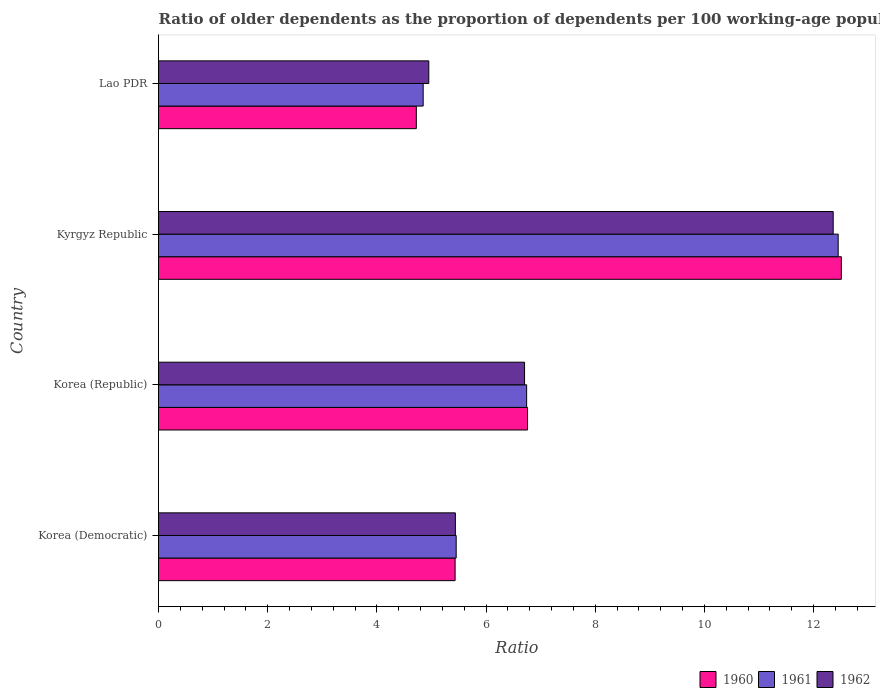How many different coloured bars are there?
Your answer should be very brief. 3. How many groups of bars are there?
Offer a terse response. 4. Are the number of bars per tick equal to the number of legend labels?
Your answer should be compact. Yes. Are the number of bars on each tick of the Y-axis equal?
Offer a terse response. Yes. How many bars are there on the 2nd tick from the bottom?
Provide a short and direct response. 3. What is the label of the 3rd group of bars from the top?
Ensure brevity in your answer.  Korea (Republic). What is the age dependency ratio(old) in 1960 in Korea (Democratic)?
Offer a very short reply. 5.43. Across all countries, what is the maximum age dependency ratio(old) in 1960?
Keep it short and to the point. 12.51. Across all countries, what is the minimum age dependency ratio(old) in 1960?
Offer a terse response. 4.72. In which country was the age dependency ratio(old) in 1960 maximum?
Your response must be concise. Kyrgyz Republic. In which country was the age dependency ratio(old) in 1961 minimum?
Provide a succinct answer. Lao PDR. What is the total age dependency ratio(old) in 1961 in the graph?
Your response must be concise. 29.49. What is the difference between the age dependency ratio(old) in 1962 in Kyrgyz Republic and that in Lao PDR?
Ensure brevity in your answer.  7.41. What is the difference between the age dependency ratio(old) in 1960 in Korea (Democratic) and the age dependency ratio(old) in 1962 in Korea (Republic)?
Your response must be concise. -1.27. What is the average age dependency ratio(old) in 1962 per country?
Your answer should be compact. 7.36. What is the difference between the age dependency ratio(old) in 1960 and age dependency ratio(old) in 1962 in Korea (Republic)?
Make the answer very short. 0.05. What is the ratio of the age dependency ratio(old) in 1962 in Kyrgyz Republic to that in Lao PDR?
Provide a succinct answer. 2.5. Is the age dependency ratio(old) in 1960 in Korea (Democratic) less than that in Lao PDR?
Your response must be concise. No. Is the difference between the age dependency ratio(old) in 1960 in Kyrgyz Republic and Lao PDR greater than the difference between the age dependency ratio(old) in 1962 in Kyrgyz Republic and Lao PDR?
Offer a very short reply. Yes. What is the difference between the highest and the second highest age dependency ratio(old) in 1962?
Your answer should be very brief. 5.65. What is the difference between the highest and the lowest age dependency ratio(old) in 1962?
Keep it short and to the point. 7.41. Is the sum of the age dependency ratio(old) in 1962 in Korea (Democratic) and Lao PDR greater than the maximum age dependency ratio(old) in 1960 across all countries?
Your answer should be very brief. No. Is it the case that in every country, the sum of the age dependency ratio(old) in 1960 and age dependency ratio(old) in 1961 is greater than the age dependency ratio(old) in 1962?
Provide a short and direct response. Yes. How many bars are there?
Provide a short and direct response. 12. Are all the bars in the graph horizontal?
Offer a very short reply. Yes. How many countries are there in the graph?
Your answer should be very brief. 4. What is the difference between two consecutive major ticks on the X-axis?
Your answer should be very brief. 2. Are the values on the major ticks of X-axis written in scientific E-notation?
Provide a succinct answer. No. Does the graph contain grids?
Provide a succinct answer. No. Where does the legend appear in the graph?
Your answer should be compact. Bottom right. How are the legend labels stacked?
Provide a succinct answer. Horizontal. What is the title of the graph?
Offer a very short reply. Ratio of older dependents as the proportion of dependents per 100 working-age population. What is the label or title of the X-axis?
Give a very brief answer. Ratio. What is the Ratio in 1960 in Korea (Democratic)?
Your answer should be compact. 5.43. What is the Ratio in 1961 in Korea (Democratic)?
Give a very brief answer. 5.45. What is the Ratio of 1962 in Korea (Democratic)?
Your answer should be compact. 5.44. What is the Ratio in 1960 in Korea (Republic)?
Your response must be concise. 6.76. What is the Ratio of 1961 in Korea (Republic)?
Your answer should be very brief. 6.74. What is the Ratio of 1962 in Korea (Republic)?
Offer a very short reply. 6.7. What is the Ratio of 1960 in Kyrgyz Republic?
Your answer should be very brief. 12.51. What is the Ratio of 1961 in Kyrgyz Republic?
Offer a very short reply. 12.45. What is the Ratio in 1962 in Kyrgyz Republic?
Your response must be concise. 12.36. What is the Ratio in 1960 in Lao PDR?
Ensure brevity in your answer.  4.72. What is the Ratio of 1961 in Lao PDR?
Your response must be concise. 4.85. What is the Ratio in 1962 in Lao PDR?
Make the answer very short. 4.95. Across all countries, what is the maximum Ratio in 1960?
Provide a succinct answer. 12.51. Across all countries, what is the maximum Ratio of 1961?
Give a very brief answer. 12.45. Across all countries, what is the maximum Ratio in 1962?
Offer a very short reply. 12.36. Across all countries, what is the minimum Ratio in 1960?
Offer a very short reply. 4.72. Across all countries, what is the minimum Ratio of 1961?
Make the answer very short. 4.85. Across all countries, what is the minimum Ratio in 1962?
Your answer should be very brief. 4.95. What is the total Ratio of 1960 in the graph?
Offer a terse response. 29.42. What is the total Ratio in 1961 in the graph?
Give a very brief answer. 29.49. What is the total Ratio of 1962 in the graph?
Provide a succinct answer. 29.45. What is the difference between the Ratio of 1960 in Korea (Democratic) and that in Korea (Republic)?
Offer a terse response. -1.33. What is the difference between the Ratio of 1961 in Korea (Democratic) and that in Korea (Republic)?
Your response must be concise. -1.29. What is the difference between the Ratio of 1962 in Korea (Democratic) and that in Korea (Republic)?
Offer a very short reply. -1.27. What is the difference between the Ratio in 1960 in Korea (Democratic) and that in Kyrgyz Republic?
Make the answer very short. -7.07. What is the difference between the Ratio of 1961 in Korea (Democratic) and that in Kyrgyz Republic?
Provide a short and direct response. -7. What is the difference between the Ratio of 1962 in Korea (Democratic) and that in Kyrgyz Republic?
Offer a very short reply. -6.92. What is the difference between the Ratio in 1960 in Korea (Democratic) and that in Lao PDR?
Offer a very short reply. 0.71. What is the difference between the Ratio of 1961 in Korea (Democratic) and that in Lao PDR?
Ensure brevity in your answer.  0.6. What is the difference between the Ratio in 1962 in Korea (Democratic) and that in Lao PDR?
Keep it short and to the point. 0.49. What is the difference between the Ratio of 1960 in Korea (Republic) and that in Kyrgyz Republic?
Provide a succinct answer. -5.75. What is the difference between the Ratio in 1961 in Korea (Republic) and that in Kyrgyz Republic?
Ensure brevity in your answer.  -5.71. What is the difference between the Ratio in 1962 in Korea (Republic) and that in Kyrgyz Republic?
Make the answer very short. -5.65. What is the difference between the Ratio of 1960 in Korea (Republic) and that in Lao PDR?
Give a very brief answer. 2.04. What is the difference between the Ratio in 1961 in Korea (Republic) and that in Lao PDR?
Your answer should be compact. 1.9. What is the difference between the Ratio in 1962 in Korea (Republic) and that in Lao PDR?
Keep it short and to the point. 1.75. What is the difference between the Ratio of 1960 in Kyrgyz Republic and that in Lao PDR?
Give a very brief answer. 7.78. What is the difference between the Ratio of 1961 in Kyrgyz Republic and that in Lao PDR?
Ensure brevity in your answer.  7.6. What is the difference between the Ratio of 1962 in Kyrgyz Republic and that in Lao PDR?
Make the answer very short. 7.41. What is the difference between the Ratio in 1960 in Korea (Democratic) and the Ratio in 1961 in Korea (Republic)?
Make the answer very short. -1.31. What is the difference between the Ratio of 1960 in Korea (Democratic) and the Ratio of 1962 in Korea (Republic)?
Offer a terse response. -1.27. What is the difference between the Ratio in 1961 in Korea (Democratic) and the Ratio in 1962 in Korea (Republic)?
Give a very brief answer. -1.25. What is the difference between the Ratio of 1960 in Korea (Democratic) and the Ratio of 1961 in Kyrgyz Republic?
Give a very brief answer. -7.02. What is the difference between the Ratio of 1960 in Korea (Democratic) and the Ratio of 1962 in Kyrgyz Republic?
Your answer should be very brief. -6.93. What is the difference between the Ratio of 1961 in Korea (Democratic) and the Ratio of 1962 in Kyrgyz Republic?
Your answer should be compact. -6.91. What is the difference between the Ratio in 1960 in Korea (Democratic) and the Ratio in 1961 in Lao PDR?
Keep it short and to the point. 0.59. What is the difference between the Ratio of 1960 in Korea (Democratic) and the Ratio of 1962 in Lao PDR?
Keep it short and to the point. 0.48. What is the difference between the Ratio of 1961 in Korea (Democratic) and the Ratio of 1962 in Lao PDR?
Keep it short and to the point. 0.5. What is the difference between the Ratio in 1960 in Korea (Republic) and the Ratio in 1961 in Kyrgyz Republic?
Ensure brevity in your answer.  -5.69. What is the difference between the Ratio in 1960 in Korea (Republic) and the Ratio in 1962 in Kyrgyz Republic?
Provide a short and direct response. -5.6. What is the difference between the Ratio in 1961 in Korea (Republic) and the Ratio in 1962 in Kyrgyz Republic?
Give a very brief answer. -5.61. What is the difference between the Ratio in 1960 in Korea (Republic) and the Ratio in 1961 in Lao PDR?
Make the answer very short. 1.91. What is the difference between the Ratio of 1960 in Korea (Republic) and the Ratio of 1962 in Lao PDR?
Offer a terse response. 1.81. What is the difference between the Ratio in 1961 in Korea (Republic) and the Ratio in 1962 in Lao PDR?
Give a very brief answer. 1.79. What is the difference between the Ratio in 1960 in Kyrgyz Republic and the Ratio in 1961 in Lao PDR?
Offer a terse response. 7.66. What is the difference between the Ratio in 1960 in Kyrgyz Republic and the Ratio in 1962 in Lao PDR?
Your answer should be compact. 7.56. What is the difference between the Ratio in 1961 in Kyrgyz Republic and the Ratio in 1962 in Lao PDR?
Provide a succinct answer. 7.5. What is the average Ratio in 1960 per country?
Keep it short and to the point. 7.36. What is the average Ratio of 1961 per country?
Keep it short and to the point. 7.37. What is the average Ratio of 1962 per country?
Provide a short and direct response. 7.36. What is the difference between the Ratio of 1960 and Ratio of 1961 in Korea (Democratic)?
Ensure brevity in your answer.  -0.02. What is the difference between the Ratio of 1960 and Ratio of 1962 in Korea (Democratic)?
Give a very brief answer. -0. What is the difference between the Ratio in 1961 and Ratio in 1962 in Korea (Democratic)?
Keep it short and to the point. 0.01. What is the difference between the Ratio in 1960 and Ratio in 1961 in Korea (Republic)?
Offer a very short reply. 0.02. What is the difference between the Ratio in 1960 and Ratio in 1962 in Korea (Republic)?
Offer a very short reply. 0.05. What is the difference between the Ratio of 1961 and Ratio of 1962 in Korea (Republic)?
Ensure brevity in your answer.  0.04. What is the difference between the Ratio of 1960 and Ratio of 1961 in Kyrgyz Republic?
Make the answer very short. 0.06. What is the difference between the Ratio in 1960 and Ratio in 1962 in Kyrgyz Republic?
Keep it short and to the point. 0.15. What is the difference between the Ratio in 1961 and Ratio in 1962 in Kyrgyz Republic?
Keep it short and to the point. 0.09. What is the difference between the Ratio in 1960 and Ratio in 1961 in Lao PDR?
Provide a short and direct response. -0.13. What is the difference between the Ratio of 1960 and Ratio of 1962 in Lao PDR?
Give a very brief answer. -0.23. What is the difference between the Ratio of 1961 and Ratio of 1962 in Lao PDR?
Your answer should be compact. -0.1. What is the ratio of the Ratio of 1960 in Korea (Democratic) to that in Korea (Republic)?
Your answer should be compact. 0.8. What is the ratio of the Ratio of 1961 in Korea (Democratic) to that in Korea (Republic)?
Make the answer very short. 0.81. What is the ratio of the Ratio in 1962 in Korea (Democratic) to that in Korea (Republic)?
Provide a short and direct response. 0.81. What is the ratio of the Ratio in 1960 in Korea (Democratic) to that in Kyrgyz Republic?
Your response must be concise. 0.43. What is the ratio of the Ratio in 1961 in Korea (Democratic) to that in Kyrgyz Republic?
Your answer should be very brief. 0.44. What is the ratio of the Ratio of 1962 in Korea (Democratic) to that in Kyrgyz Republic?
Offer a terse response. 0.44. What is the ratio of the Ratio in 1960 in Korea (Democratic) to that in Lao PDR?
Keep it short and to the point. 1.15. What is the ratio of the Ratio of 1961 in Korea (Democratic) to that in Lao PDR?
Keep it short and to the point. 1.12. What is the ratio of the Ratio of 1962 in Korea (Democratic) to that in Lao PDR?
Your answer should be very brief. 1.1. What is the ratio of the Ratio in 1960 in Korea (Republic) to that in Kyrgyz Republic?
Your answer should be compact. 0.54. What is the ratio of the Ratio in 1961 in Korea (Republic) to that in Kyrgyz Republic?
Your answer should be compact. 0.54. What is the ratio of the Ratio in 1962 in Korea (Republic) to that in Kyrgyz Republic?
Offer a very short reply. 0.54. What is the ratio of the Ratio in 1960 in Korea (Republic) to that in Lao PDR?
Make the answer very short. 1.43. What is the ratio of the Ratio of 1961 in Korea (Republic) to that in Lao PDR?
Keep it short and to the point. 1.39. What is the ratio of the Ratio of 1962 in Korea (Republic) to that in Lao PDR?
Make the answer very short. 1.35. What is the ratio of the Ratio in 1960 in Kyrgyz Republic to that in Lao PDR?
Your answer should be compact. 2.65. What is the ratio of the Ratio of 1961 in Kyrgyz Republic to that in Lao PDR?
Offer a very short reply. 2.57. What is the ratio of the Ratio in 1962 in Kyrgyz Republic to that in Lao PDR?
Your answer should be very brief. 2.5. What is the difference between the highest and the second highest Ratio of 1960?
Keep it short and to the point. 5.75. What is the difference between the highest and the second highest Ratio of 1961?
Keep it short and to the point. 5.71. What is the difference between the highest and the second highest Ratio of 1962?
Your response must be concise. 5.65. What is the difference between the highest and the lowest Ratio of 1960?
Ensure brevity in your answer.  7.78. What is the difference between the highest and the lowest Ratio in 1961?
Offer a terse response. 7.6. What is the difference between the highest and the lowest Ratio of 1962?
Make the answer very short. 7.41. 